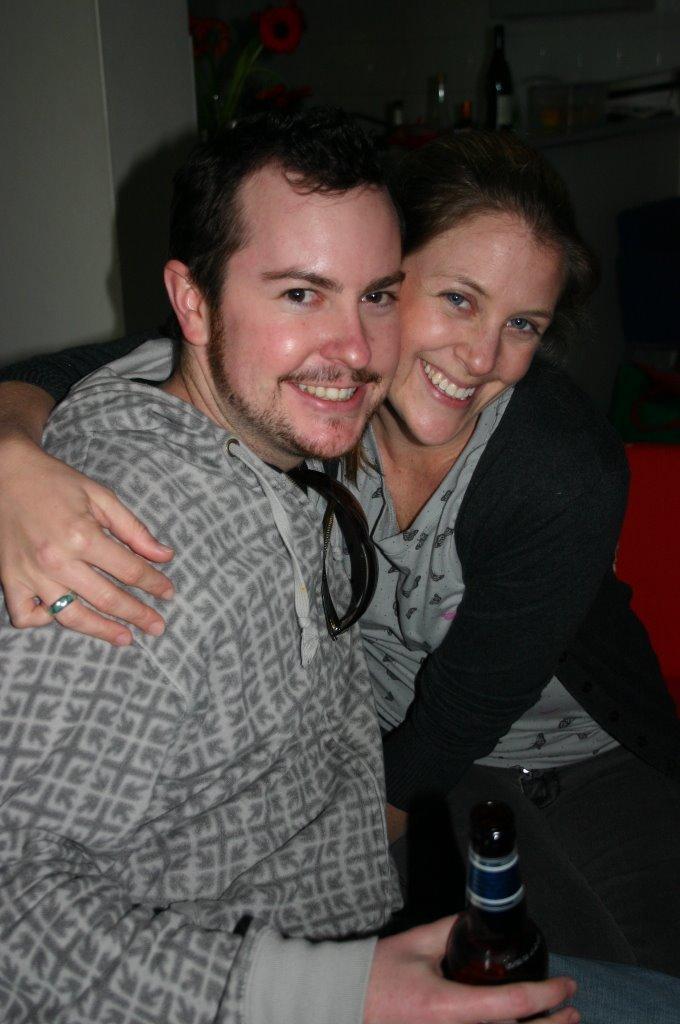How would you summarize this image in a sentence or two? In this image we can see two persons and a person in the foreground is holding a bottle. Behind the persons we can see a wall and few objects. 